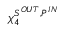<formula> <loc_0><loc_0><loc_500><loc_500>\chi _ { 4 } ^ { S ^ { O U T } , P ^ { I N } }</formula> 